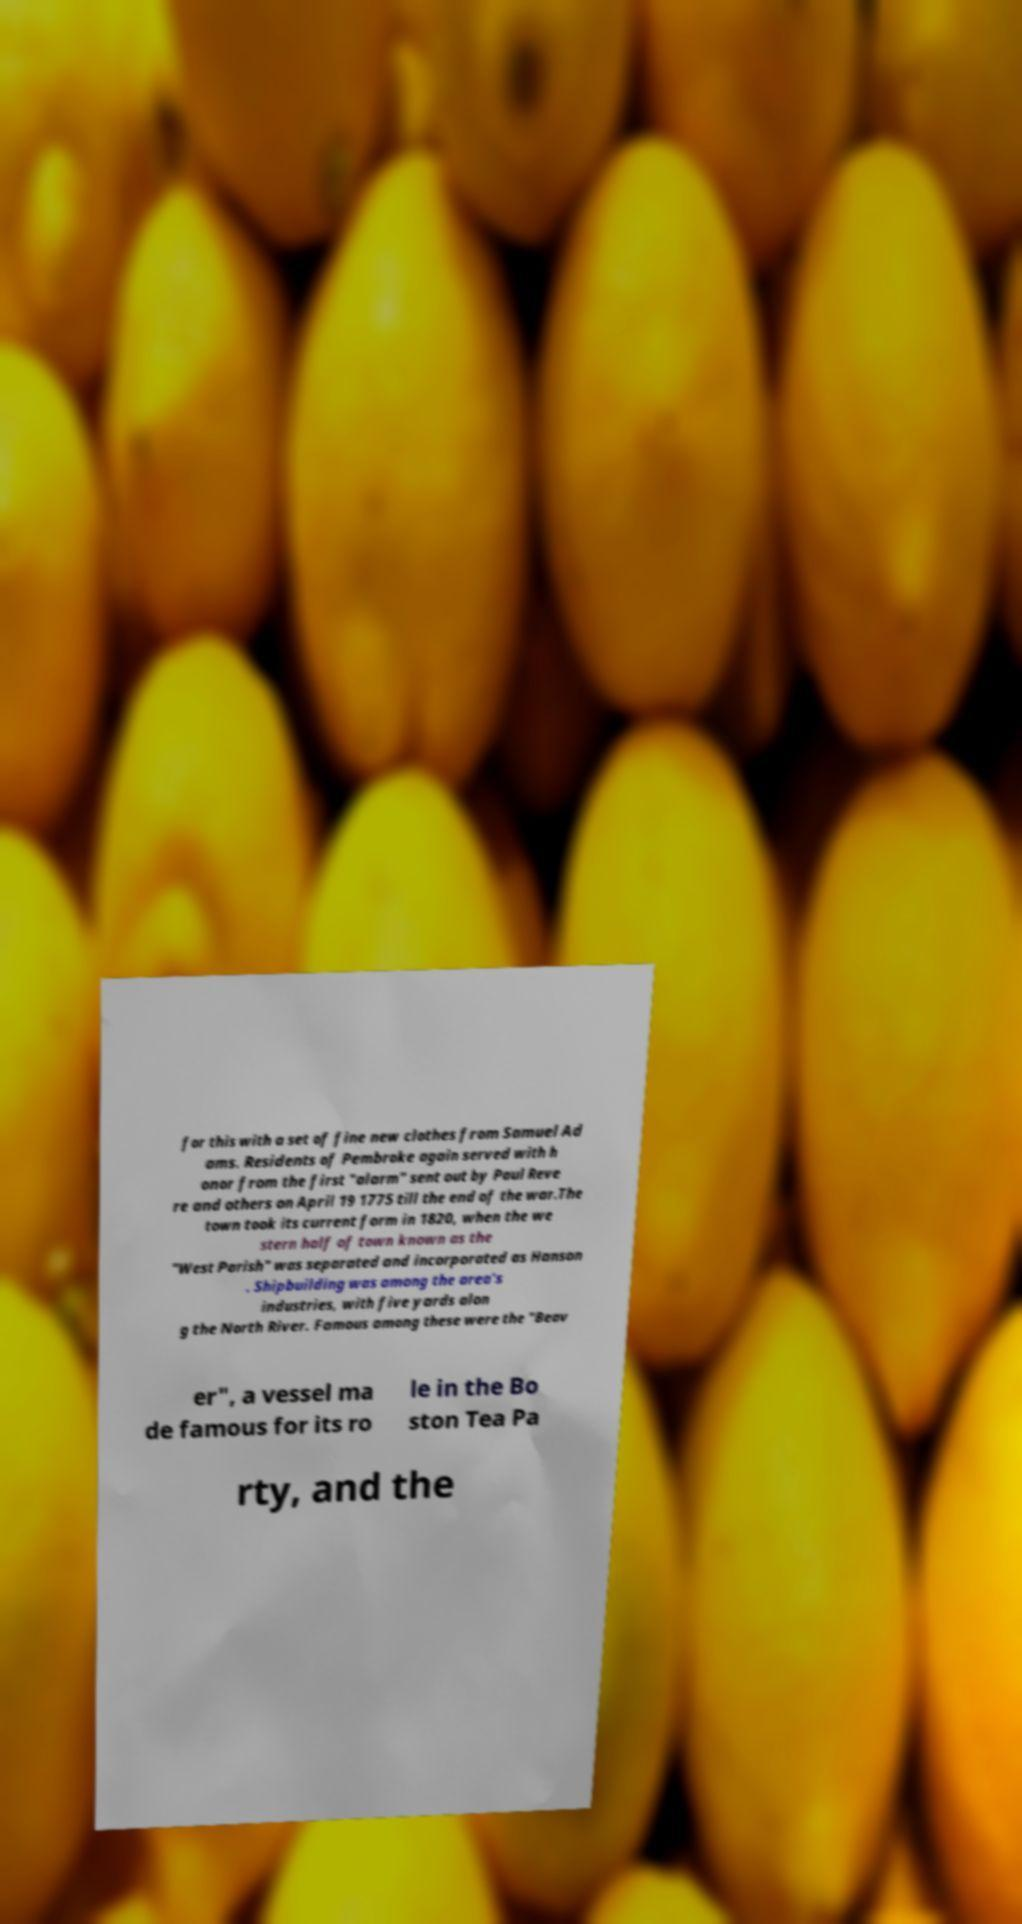For documentation purposes, I need the text within this image transcribed. Could you provide that? for this with a set of fine new clothes from Samuel Ad ams. Residents of Pembroke again served with h onor from the first "alarm" sent out by Paul Reve re and others on April 19 1775 till the end of the war.The town took its current form in 1820, when the we stern half of town known as the "West Parish" was separated and incorporated as Hanson . Shipbuilding was among the area's industries, with five yards alon g the North River. Famous among these were the "Beav er", a vessel ma de famous for its ro le in the Bo ston Tea Pa rty, and the 